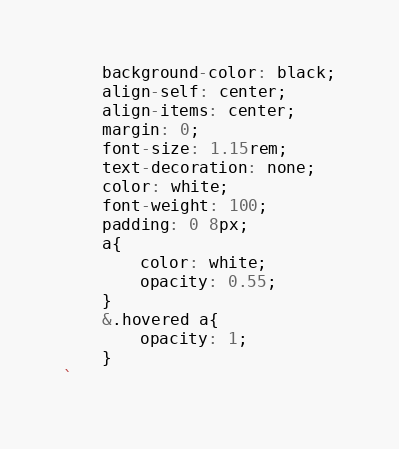Convert code to text. <code><loc_0><loc_0><loc_500><loc_500><_JavaScript_>    background-color: black;
    align-self: center;
    align-items: center;
    margin: 0;
    font-size: 1.15rem;
    text-decoration: none;
    color: white;
    font-weight: 100;
    padding: 0 8px;
    a{
        color: white;
        opacity: 0.55;
    }
    &.hovered a{
        opacity: 1;
    }
`</code> 